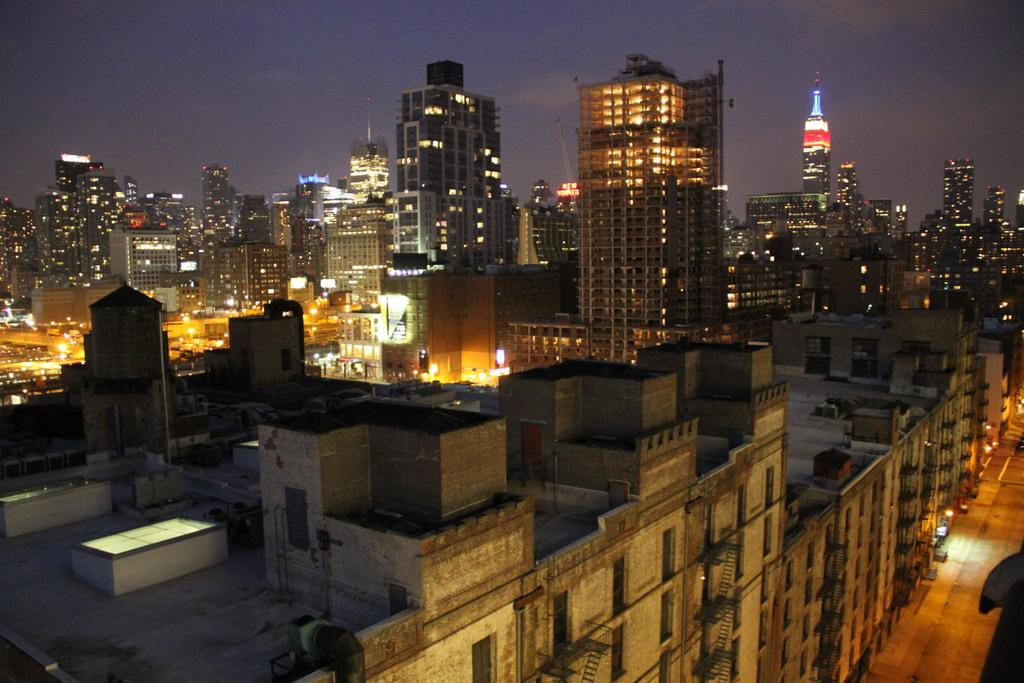Where was the image taken? The image was clicked outside the city. What can be seen on the right side of the image? There is ground visible on the right side of the image. What is present on the left side of the image? There are buildings, skyscrapers, and a minaret on the left side of the image. What part of the natural environment is visible in the image? The sky is visible in the image. What else can be seen in the image? There are lights visible in the image. How many women are visible in the image? There is no mention of women in the provided facts, so we cannot determine the number of women present in the image. 